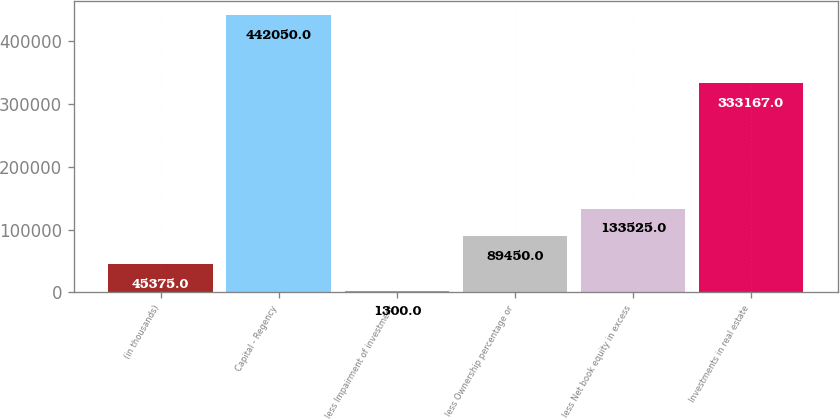Convert chart to OTSL. <chart><loc_0><loc_0><loc_500><loc_500><bar_chart><fcel>(in thousands)<fcel>Capital - Regency<fcel>less Impairment of investment<fcel>less Ownership percentage or<fcel>less Net book equity in excess<fcel>Investments in real estate<nl><fcel>45375<fcel>442050<fcel>1300<fcel>89450<fcel>133525<fcel>333167<nl></chart> 